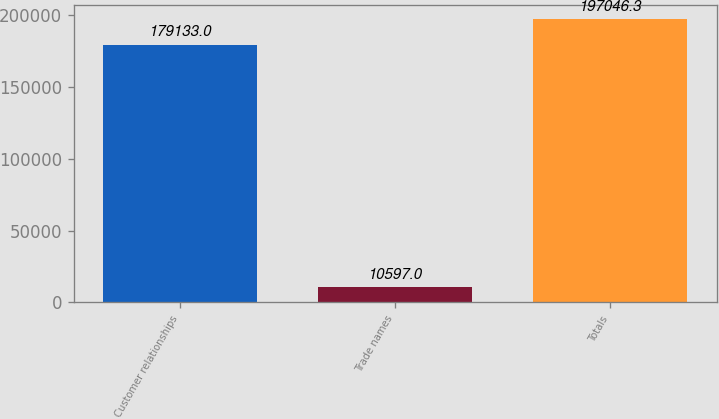Convert chart to OTSL. <chart><loc_0><loc_0><loc_500><loc_500><bar_chart><fcel>Customer relationships<fcel>Trade names<fcel>Totals<nl><fcel>179133<fcel>10597<fcel>197046<nl></chart> 